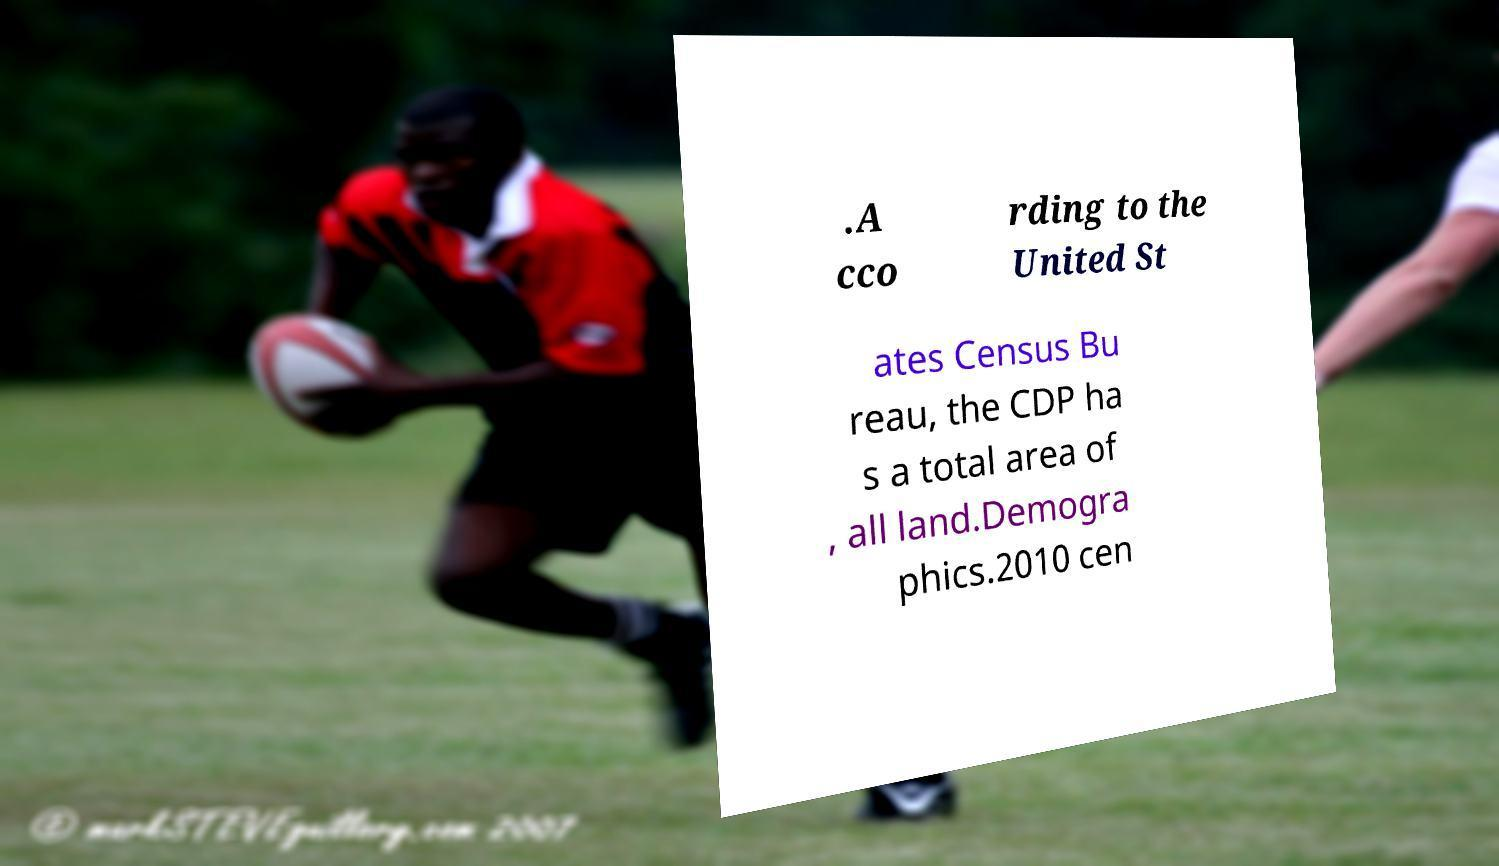Could you assist in decoding the text presented in this image and type it out clearly? .A cco rding to the United St ates Census Bu reau, the CDP ha s a total area of , all land.Demogra phics.2010 cen 